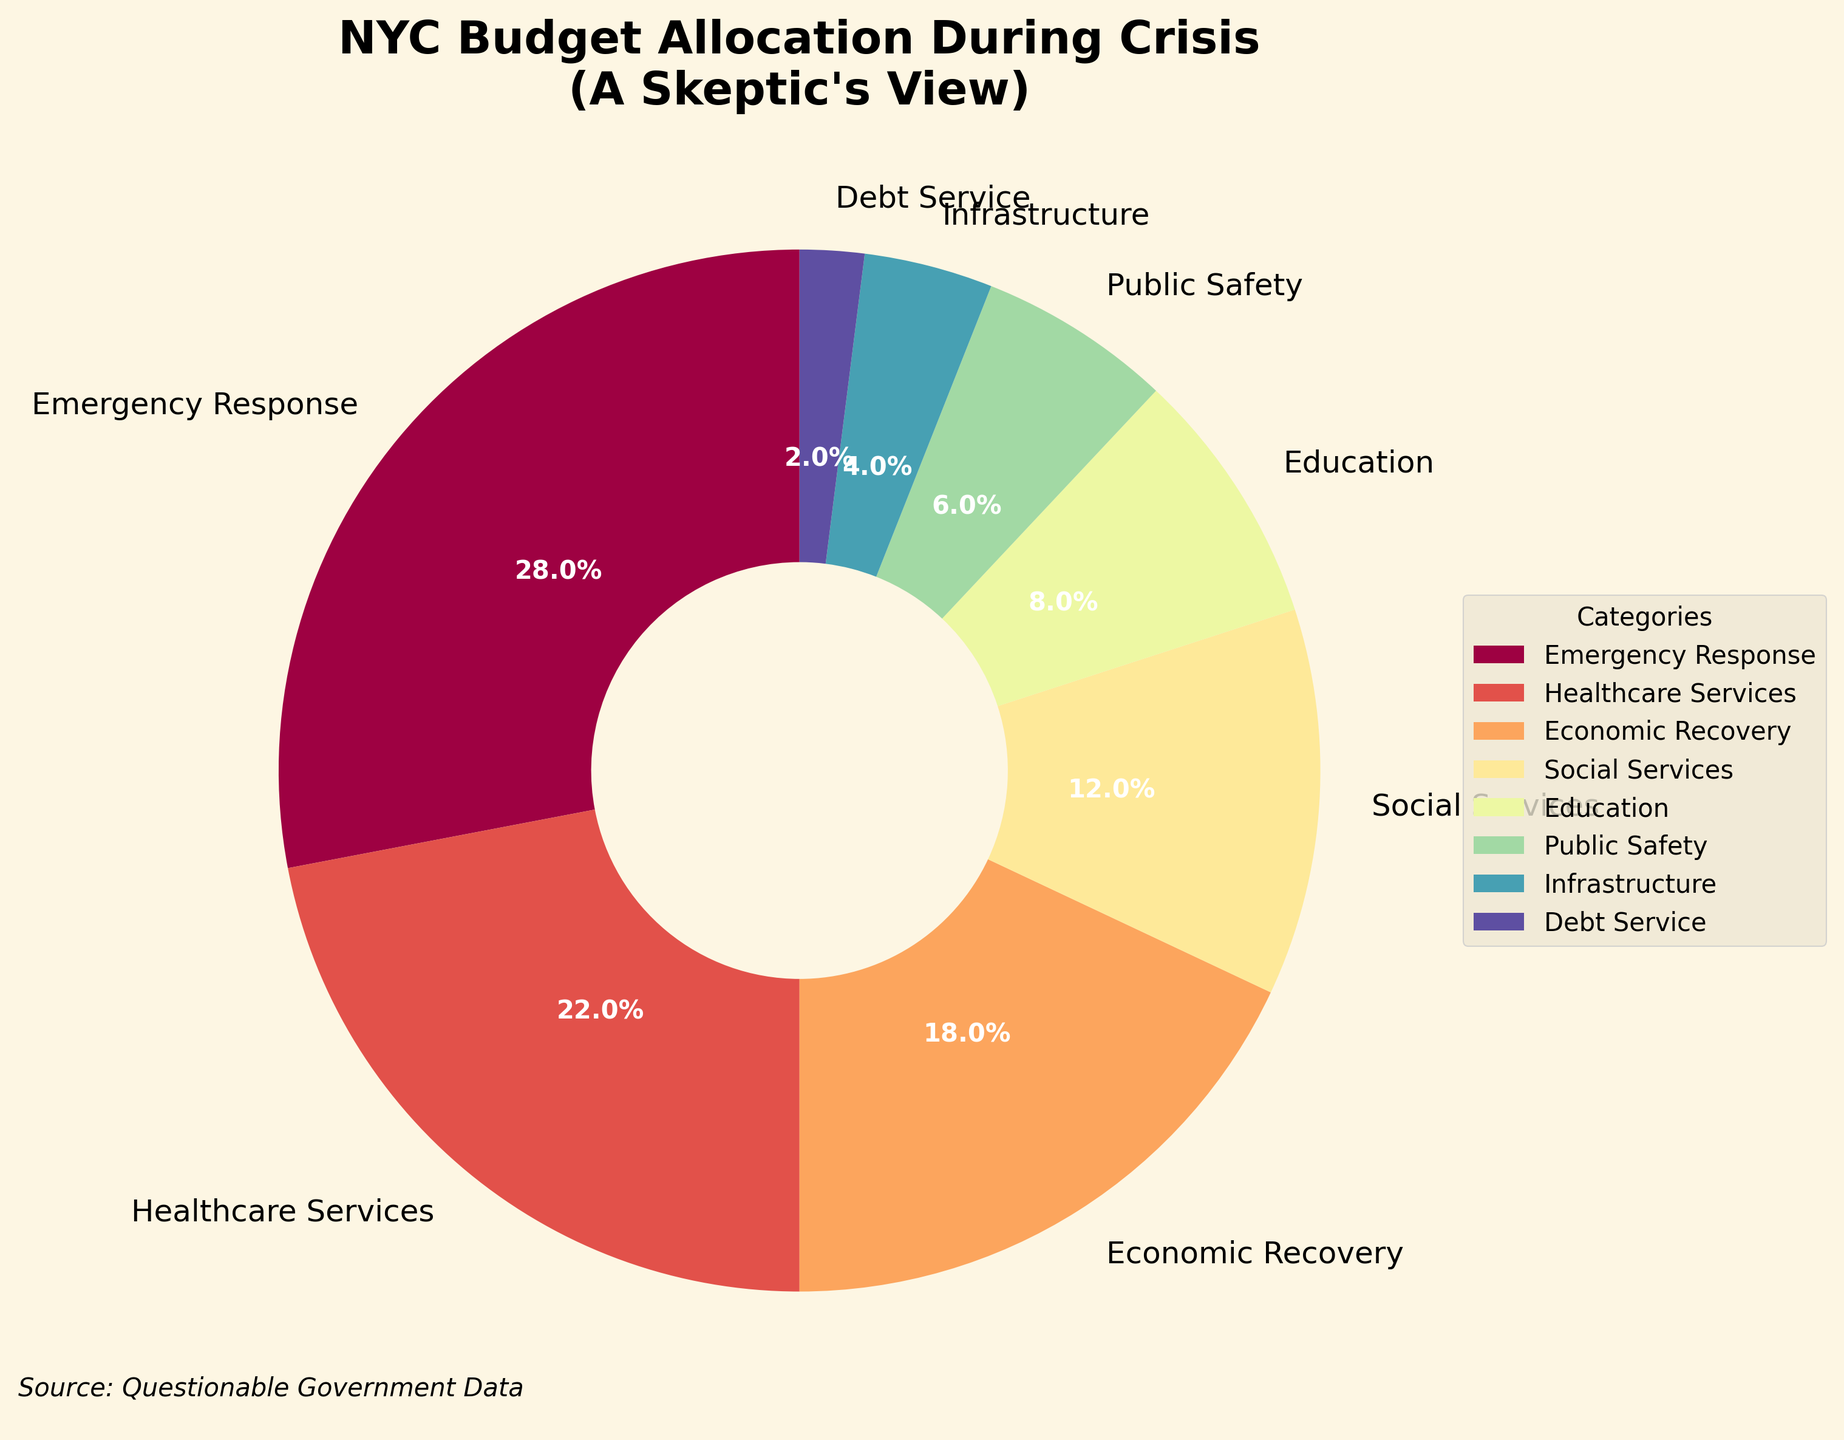What category receives the highest percentage of the budget? Locate the segment with the largest slice comparing its size to others. The segment labeled 'Emergency Response' visually represents the largest portion at 28%.
Answer: Emergency Response Which categories receive the equal lowest percentage of the budget? Identify categories with the smallest slices. Both 'Debt Service' and 'Infrastructure' have noticeably smaller slices compared to others, each representing roughly 2% and 4% respectively.
Answer: Debt Service and Infrastructure How much more is allocated to Emergency Response than Healthcare Services? Calculate the difference between the 'Emergency Response' and 'Healthcare Services' percentages. Emergency Response is 28% and Healthcare Services is 22%. So, \( 28\% - 22\% = 6\% \).
Answer: 6% What is the combined budget allocation percentage for Infrastructure and Education? Sum the percentages for 'Infrastructure' (4%) and 'Education' (8%). So, \( 4\% + 8\% = 12\% \).
Answer: 12% Is Economic Recovery allocated more or less than Healthcare Services? Compare the slices labeled 'Economic Recovery' and 'Healthcare Services'. Healthcare Services (22%) has a noticeably larger slice than Economic Recovery (18%).
Answer: Less Which category is represented by the purple wedge? Identify the segment colored in purple, considering the range of colors used in the spectrum. The purple wedge corresponds to 'Public Safety'.
Answer: Public Safety By how much does the allocation for Social Services differ from that of Public Safety? Calculate the difference between the percentages for 'Social Services' (12%) and 'Public Safety' (6%). So, \( 12\% - 6\% = 6\% \).
Answer: 6% What percentage of the budget is allocated to non-safety-related services (excluding Emergency Response and Public Safety)? Summing up the percentages of all categories except 'Emergency Response' and 'Public Safety'. Healthcare Services (22%) + Economic Recovery (18%) + Social Services (12%) + Education (8%) + Infrastructure (4%) + Debt Service (2%) = 66%.
Answer: 66% Which categories have a percentage allocation above 10%? Identify the categories which have a percentage value higher than 10%. These include 'Emergency Response' (28%), 'Healthcare Services' (22%), 'Economic Recovery' (18%), and 'Social Services' (12%).
Answer: Emergency Response, Healthcare Services, Economic Recovery, and Social Services What is the ratio of the combined allocation for Healthcare Services and Emergency Response to the total budget? Calculate the sum of these categories and form the ratio to the overall percentage. \( \frac{28\% + 22\%}{100\%} = \frac{50\%}{100\%} = 0.5 \). Thus, the ratio is 1:2.
Answer: 1:2 